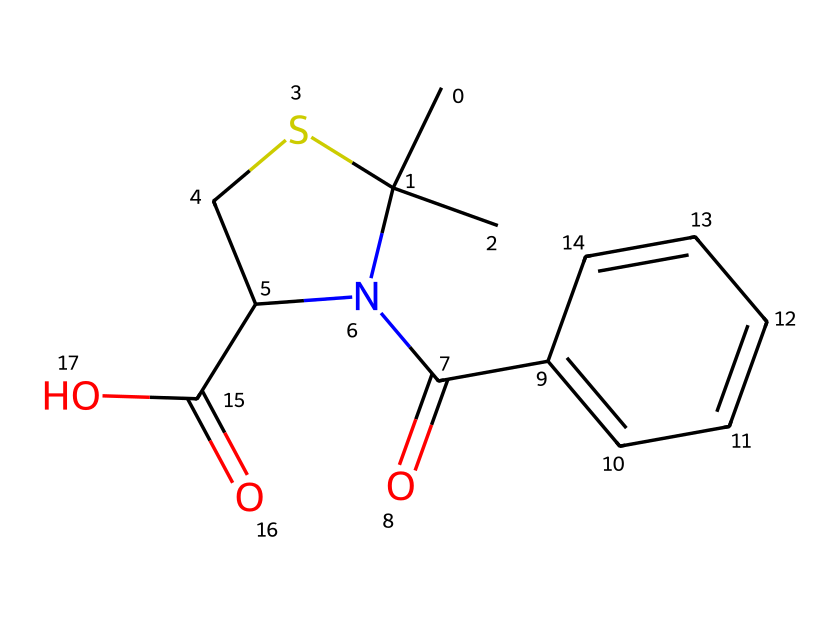What is the main functional group in this molecule? This molecule contains a carboxylic acid group, which is indicated by the presence of -COOH. The -COOH group is characteristic of acidic compounds.
Answer: carboxylic acid How many nitrogen atoms are present in this structure? By analyzing the SMILES representation, we can count the nitrogen atoms. In this case, there is one nitrogen atom present.
Answer: 1 What type of drug is penicillin classified as? Penicillin is classified as a beta-lactam antibiotic, which is evident from its core structure that includes a beta-lactam ring. This classification is based on its mechanism of action against bacteria.
Answer: antibiotic What is the total number of carbon atoms in the molecule? The structure reveals a total of 12 carbon atoms when counted from the SMILES representation, which provides the backbone of the penicillin molecule.
Answer: 12 Is this molecule likely to be soluble in water? Given the presence of the carboxylic acid group and the overall polar characteristics of the molecule, it suggests that this drug would be soluble in water due to its ability to form hydrogen bonds.
Answer: yes What is the role of the thiazolidine ring in penicillin? The thiazolidine ring plays a crucial role in the stability of penicillin and its biological activity, providing a scaffold that is important for its antimicrobial properties and interaction with bacterial enzymes.
Answer: stability What determines the antibiotic potency of penicillin? The antibiotic potency of penicillin is determined by the arrangement of its functional groups, especially the beta-lactam ring and the side chain, which influence its effectiveness against specific types of bacteria.
Answer: functional groups 